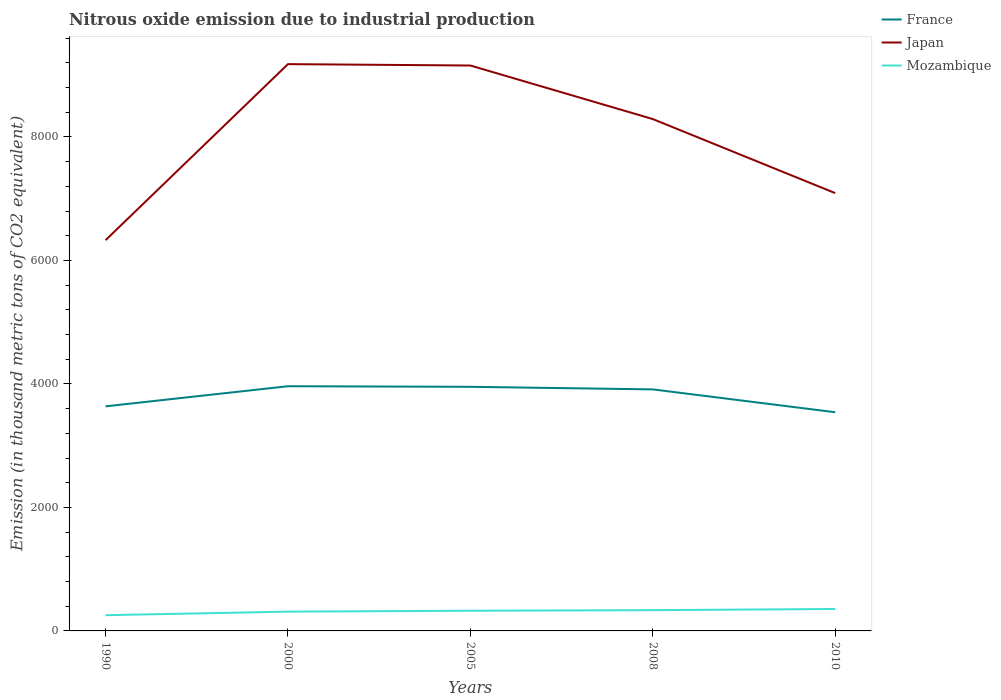Does the line corresponding to Japan intersect with the line corresponding to Mozambique?
Your response must be concise. No. Is the number of lines equal to the number of legend labels?
Your response must be concise. Yes. Across all years, what is the maximum amount of nitrous oxide emitted in Japan?
Offer a very short reply. 6328.4. In which year was the amount of nitrous oxide emitted in France maximum?
Your answer should be very brief. 2010. What is the total amount of nitrous oxide emitted in Mozambique in the graph?
Keep it short and to the point. -100.5. What is the difference between the highest and the second highest amount of nitrous oxide emitted in France?
Keep it short and to the point. 421.1. What is the difference between the highest and the lowest amount of nitrous oxide emitted in Mozambique?
Ensure brevity in your answer.  3. What is the difference between two consecutive major ticks on the Y-axis?
Keep it short and to the point. 2000. Does the graph contain any zero values?
Provide a short and direct response. No. Does the graph contain grids?
Ensure brevity in your answer.  No. How many legend labels are there?
Provide a succinct answer. 3. What is the title of the graph?
Keep it short and to the point. Nitrous oxide emission due to industrial production. Does "Saudi Arabia" appear as one of the legend labels in the graph?
Make the answer very short. No. What is the label or title of the Y-axis?
Offer a very short reply. Emission (in thousand metric tons of CO2 equivalent). What is the Emission (in thousand metric tons of CO2 equivalent) of France in 1990?
Provide a short and direct response. 3637.1. What is the Emission (in thousand metric tons of CO2 equivalent) in Japan in 1990?
Keep it short and to the point. 6328.4. What is the Emission (in thousand metric tons of CO2 equivalent) of Mozambique in 1990?
Keep it short and to the point. 254.8. What is the Emission (in thousand metric tons of CO2 equivalent) of France in 2000?
Keep it short and to the point. 3963. What is the Emission (in thousand metric tons of CO2 equivalent) of Japan in 2000?
Your answer should be very brief. 9179.4. What is the Emission (in thousand metric tons of CO2 equivalent) of Mozambique in 2000?
Make the answer very short. 312.2. What is the Emission (in thousand metric tons of CO2 equivalent) in France in 2005?
Your answer should be very brief. 3953.5. What is the Emission (in thousand metric tons of CO2 equivalent) of Japan in 2005?
Ensure brevity in your answer.  9157. What is the Emission (in thousand metric tons of CO2 equivalent) in Mozambique in 2005?
Offer a terse response. 326.9. What is the Emission (in thousand metric tons of CO2 equivalent) in France in 2008?
Offer a very short reply. 3911.7. What is the Emission (in thousand metric tons of CO2 equivalent) in Japan in 2008?
Make the answer very short. 8290. What is the Emission (in thousand metric tons of CO2 equivalent) of Mozambique in 2008?
Give a very brief answer. 336.3. What is the Emission (in thousand metric tons of CO2 equivalent) in France in 2010?
Your response must be concise. 3541.9. What is the Emission (in thousand metric tons of CO2 equivalent) of Japan in 2010?
Provide a short and direct response. 7090.6. What is the Emission (in thousand metric tons of CO2 equivalent) of Mozambique in 2010?
Your answer should be compact. 355.3. Across all years, what is the maximum Emission (in thousand metric tons of CO2 equivalent) in France?
Your answer should be compact. 3963. Across all years, what is the maximum Emission (in thousand metric tons of CO2 equivalent) in Japan?
Provide a short and direct response. 9179.4. Across all years, what is the maximum Emission (in thousand metric tons of CO2 equivalent) of Mozambique?
Provide a succinct answer. 355.3. Across all years, what is the minimum Emission (in thousand metric tons of CO2 equivalent) in France?
Give a very brief answer. 3541.9. Across all years, what is the minimum Emission (in thousand metric tons of CO2 equivalent) in Japan?
Your answer should be compact. 6328.4. Across all years, what is the minimum Emission (in thousand metric tons of CO2 equivalent) of Mozambique?
Your answer should be compact. 254.8. What is the total Emission (in thousand metric tons of CO2 equivalent) of France in the graph?
Your answer should be compact. 1.90e+04. What is the total Emission (in thousand metric tons of CO2 equivalent) of Japan in the graph?
Offer a terse response. 4.00e+04. What is the total Emission (in thousand metric tons of CO2 equivalent) in Mozambique in the graph?
Ensure brevity in your answer.  1585.5. What is the difference between the Emission (in thousand metric tons of CO2 equivalent) of France in 1990 and that in 2000?
Give a very brief answer. -325.9. What is the difference between the Emission (in thousand metric tons of CO2 equivalent) of Japan in 1990 and that in 2000?
Offer a terse response. -2851. What is the difference between the Emission (in thousand metric tons of CO2 equivalent) of Mozambique in 1990 and that in 2000?
Your answer should be compact. -57.4. What is the difference between the Emission (in thousand metric tons of CO2 equivalent) of France in 1990 and that in 2005?
Your answer should be compact. -316.4. What is the difference between the Emission (in thousand metric tons of CO2 equivalent) in Japan in 1990 and that in 2005?
Your answer should be compact. -2828.6. What is the difference between the Emission (in thousand metric tons of CO2 equivalent) in Mozambique in 1990 and that in 2005?
Your answer should be very brief. -72.1. What is the difference between the Emission (in thousand metric tons of CO2 equivalent) in France in 1990 and that in 2008?
Your response must be concise. -274.6. What is the difference between the Emission (in thousand metric tons of CO2 equivalent) in Japan in 1990 and that in 2008?
Your response must be concise. -1961.6. What is the difference between the Emission (in thousand metric tons of CO2 equivalent) of Mozambique in 1990 and that in 2008?
Your response must be concise. -81.5. What is the difference between the Emission (in thousand metric tons of CO2 equivalent) in France in 1990 and that in 2010?
Provide a short and direct response. 95.2. What is the difference between the Emission (in thousand metric tons of CO2 equivalent) in Japan in 1990 and that in 2010?
Provide a short and direct response. -762.2. What is the difference between the Emission (in thousand metric tons of CO2 equivalent) of Mozambique in 1990 and that in 2010?
Your response must be concise. -100.5. What is the difference between the Emission (in thousand metric tons of CO2 equivalent) in France in 2000 and that in 2005?
Keep it short and to the point. 9.5. What is the difference between the Emission (in thousand metric tons of CO2 equivalent) in Japan in 2000 and that in 2005?
Ensure brevity in your answer.  22.4. What is the difference between the Emission (in thousand metric tons of CO2 equivalent) of Mozambique in 2000 and that in 2005?
Provide a succinct answer. -14.7. What is the difference between the Emission (in thousand metric tons of CO2 equivalent) in France in 2000 and that in 2008?
Your answer should be very brief. 51.3. What is the difference between the Emission (in thousand metric tons of CO2 equivalent) of Japan in 2000 and that in 2008?
Your response must be concise. 889.4. What is the difference between the Emission (in thousand metric tons of CO2 equivalent) of Mozambique in 2000 and that in 2008?
Your answer should be compact. -24.1. What is the difference between the Emission (in thousand metric tons of CO2 equivalent) of France in 2000 and that in 2010?
Provide a succinct answer. 421.1. What is the difference between the Emission (in thousand metric tons of CO2 equivalent) of Japan in 2000 and that in 2010?
Offer a very short reply. 2088.8. What is the difference between the Emission (in thousand metric tons of CO2 equivalent) of Mozambique in 2000 and that in 2010?
Keep it short and to the point. -43.1. What is the difference between the Emission (in thousand metric tons of CO2 equivalent) of France in 2005 and that in 2008?
Keep it short and to the point. 41.8. What is the difference between the Emission (in thousand metric tons of CO2 equivalent) in Japan in 2005 and that in 2008?
Make the answer very short. 867. What is the difference between the Emission (in thousand metric tons of CO2 equivalent) in Mozambique in 2005 and that in 2008?
Your response must be concise. -9.4. What is the difference between the Emission (in thousand metric tons of CO2 equivalent) in France in 2005 and that in 2010?
Give a very brief answer. 411.6. What is the difference between the Emission (in thousand metric tons of CO2 equivalent) in Japan in 2005 and that in 2010?
Provide a short and direct response. 2066.4. What is the difference between the Emission (in thousand metric tons of CO2 equivalent) in Mozambique in 2005 and that in 2010?
Keep it short and to the point. -28.4. What is the difference between the Emission (in thousand metric tons of CO2 equivalent) of France in 2008 and that in 2010?
Offer a very short reply. 369.8. What is the difference between the Emission (in thousand metric tons of CO2 equivalent) of Japan in 2008 and that in 2010?
Offer a very short reply. 1199.4. What is the difference between the Emission (in thousand metric tons of CO2 equivalent) of France in 1990 and the Emission (in thousand metric tons of CO2 equivalent) of Japan in 2000?
Make the answer very short. -5542.3. What is the difference between the Emission (in thousand metric tons of CO2 equivalent) in France in 1990 and the Emission (in thousand metric tons of CO2 equivalent) in Mozambique in 2000?
Your response must be concise. 3324.9. What is the difference between the Emission (in thousand metric tons of CO2 equivalent) in Japan in 1990 and the Emission (in thousand metric tons of CO2 equivalent) in Mozambique in 2000?
Give a very brief answer. 6016.2. What is the difference between the Emission (in thousand metric tons of CO2 equivalent) in France in 1990 and the Emission (in thousand metric tons of CO2 equivalent) in Japan in 2005?
Give a very brief answer. -5519.9. What is the difference between the Emission (in thousand metric tons of CO2 equivalent) of France in 1990 and the Emission (in thousand metric tons of CO2 equivalent) of Mozambique in 2005?
Your answer should be very brief. 3310.2. What is the difference between the Emission (in thousand metric tons of CO2 equivalent) of Japan in 1990 and the Emission (in thousand metric tons of CO2 equivalent) of Mozambique in 2005?
Provide a short and direct response. 6001.5. What is the difference between the Emission (in thousand metric tons of CO2 equivalent) in France in 1990 and the Emission (in thousand metric tons of CO2 equivalent) in Japan in 2008?
Offer a very short reply. -4652.9. What is the difference between the Emission (in thousand metric tons of CO2 equivalent) in France in 1990 and the Emission (in thousand metric tons of CO2 equivalent) in Mozambique in 2008?
Your answer should be compact. 3300.8. What is the difference between the Emission (in thousand metric tons of CO2 equivalent) of Japan in 1990 and the Emission (in thousand metric tons of CO2 equivalent) of Mozambique in 2008?
Your answer should be compact. 5992.1. What is the difference between the Emission (in thousand metric tons of CO2 equivalent) of France in 1990 and the Emission (in thousand metric tons of CO2 equivalent) of Japan in 2010?
Your answer should be very brief. -3453.5. What is the difference between the Emission (in thousand metric tons of CO2 equivalent) in France in 1990 and the Emission (in thousand metric tons of CO2 equivalent) in Mozambique in 2010?
Your answer should be very brief. 3281.8. What is the difference between the Emission (in thousand metric tons of CO2 equivalent) of Japan in 1990 and the Emission (in thousand metric tons of CO2 equivalent) of Mozambique in 2010?
Keep it short and to the point. 5973.1. What is the difference between the Emission (in thousand metric tons of CO2 equivalent) of France in 2000 and the Emission (in thousand metric tons of CO2 equivalent) of Japan in 2005?
Make the answer very short. -5194. What is the difference between the Emission (in thousand metric tons of CO2 equivalent) of France in 2000 and the Emission (in thousand metric tons of CO2 equivalent) of Mozambique in 2005?
Ensure brevity in your answer.  3636.1. What is the difference between the Emission (in thousand metric tons of CO2 equivalent) of Japan in 2000 and the Emission (in thousand metric tons of CO2 equivalent) of Mozambique in 2005?
Your response must be concise. 8852.5. What is the difference between the Emission (in thousand metric tons of CO2 equivalent) in France in 2000 and the Emission (in thousand metric tons of CO2 equivalent) in Japan in 2008?
Your answer should be very brief. -4327. What is the difference between the Emission (in thousand metric tons of CO2 equivalent) of France in 2000 and the Emission (in thousand metric tons of CO2 equivalent) of Mozambique in 2008?
Make the answer very short. 3626.7. What is the difference between the Emission (in thousand metric tons of CO2 equivalent) in Japan in 2000 and the Emission (in thousand metric tons of CO2 equivalent) in Mozambique in 2008?
Give a very brief answer. 8843.1. What is the difference between the Emission (in thousand metric tons of CO2 equivalent) in France in 2000 and the Emission (in thousand metric tons of CO2 equivalent) in Japan in 2010?
Your answer should be compact. -3127.6. What is the difference between the Emission (in thousand metric tons of CO2 equivalent) of France in 2000 and the Emission (in thousand metric tons of CO2 equivalent) of Mozambique in 2010?
Keep it short and to the point. 3607.7. What is the difference between the Emission (in thousand metric tons of CO2 equivalent) of Japan in 2000 and the Emission (in thousand metric tons of CO2 equivalent) of Mozambique in 2010?
Offer a very short reply. 8824.1. What is the difference between the Emission (in thousand metric tons of CO2 equivalent) of France in 2005 and the Emission (in thousand metric tons of CO2 equivalent) of Japan in 2008?
Give a very brief answer. -4336.5. What is the difference between the Emission (in thousand metric tons of CO2 equivalent) of France in 2005 and the Emission (in thousand metric tons of CO2 equivalent) of Mozambique in 2008?
Your response must be concise. 3617.2. What is the difference between the Emission (in thousand metric tons of CO2 equivalent) in Japan in 2005 and the Emission (in thousand metric tons of CO2 equivalent) in Mozambique in 2008?
Keep it short and to the point. 8820.7. What is the difference between the Emission (in thousand metric tons of CO2 equivalent) of France in 2005 and the Emission (in thousand metric tons of CO2 equivalent) of Japan in 2010?
Make the answer very short. -3137.1. What is the difference between the Emission (in thousand metric tons of CO2 equivalent) of France in 2005 and the Emission (in thousand metric tons of CO2 equivalent) of Mozambique in 2010?
Your answer should be compact. 3598.2. What is the difference between the Emission (in thousand metric tons of CO2 equivalent) in Japan in 2005 and the Emission (in thousand metric tons of CO2 equivalent) in Mozambique in 2010?
Your answer should be compact. 8801.7. What is the difference between the Emission (in thousand metric tons of CO2 equivalent) of France in 2008 and the Emission (in thousand metric tons of CO2 equivalent) of Japan in 2010?
Ensure brevity in your answer.  -3178.9. What is the difference between the Emission (in thousand metric tons of CO2 equivalent) in France in 2008 and the Emission (in thousand metric tons of CO2 equivalent) in Mozambique in 2010?
Offer a terse response. 3556.4. What is the difference between the Emission (in thousand metric tons of CO2 equivalent) of Japan in 2008 and the Emission (in thousand metric tons of CO2 equivalent) of Mozambique in 2010?
Provide a succinct answer. 7934.7. What is the average Emission (in thousand metric tons of CO2 equivalent) in France per year?
Ensure brevity in your answer.  3801.44. What is the average Emission (in thousand metric tons of CO2 equivalent) of Japan per year?
Make the answer very short. 8009.08. What is the average Emission (in thousand metric tons of CO2 equivalent) of Mozambique per year?
Offer a very short reply. 317.1. In the year 1990, what is the difference between the Emission (in thousand metric tons of CO2 equivalent) in France and Emission (in thousand metric tons of CO2 equivalent) in Japan?
Ensure brevity in your answer.  -2691.3. In the year 1990, what is the difference between the Emission (in thousand metric tons of CO2 equivalent) in France and Emission (in thousand metric tons of CO2 equivalent) in Mozambique?
Provide a short and direct response. 3382.3. In the year 1990, what is the difference between the Emission (in thousand metric tons of CO2 equivalent) in Japan and Emission (in thousand metric tons of CO2 equivalent) in Mozambique?
Your response must be concise. 6073.6. In the year 2000, what is the difference between the Emission (in thousand metric tons of CO2 equivalent) of France and Emission (in thousand metric tons of CO2 equivalent) of Japan?
Make the answer very short. -5216.4. In the year 2000, what is the difference between the Emission (in thousand metric tons of CO2 equivalent) in France and Emission (in thousand metric tons of CO2 equivalent) in Mozambique?
Give a very brief answer. 3650.8. In the year 2000, what is the difference between the Emission (in thousand metric tons of CO2 equivalent) in Japan and Emission (in thousand metric tons of CO2 equivalent) in Mozambique?
Offer a terse response. 8867.2. In the year 2005, what is the difference between the Emission (in thousand metric tons of CO2 equivalent) of France and Emission (in thousand metric tons of CO2 equivalent) of Japan?
Ensure brevity in your answer.  -5203.5. In the year 2005, what is the difference between the Emission (in thousand metric tons of CO2 equivalent) in France and Emission (in thousand metric tons of CO2 equivalent) in Mozambique?
Provide a succinct answer. 3626.6. In the year 2005, what is the difference between the Emission (in thousand metric tons of CO2 equivalent) in Japan and Emission (in thousand metric tons of CO2 equivalent) in Mozambique?
Provide a short and direct response. 8830.1. In the year 2008, what is the difference between the Emission (in thousand metric tons of CO2 equivalent) of France and Emission (in thousand metric tons of CO2 equivalent) of Japan?
Your answer should be very brief. -4378.3. In the year 2008, what is the difference between the Emission (in thousand metric tons of CO2 equivalent) of France and Emission (in thousand metric tons of CO2 equivalent) of Mozambique?
Give a very brief answer. 3575.4. In the year 2008, what is the difference between the Emission (in thousand metric tons of CO2 equivalent) in Japan and Emission (in thousand metric tons of CO2 equivalent) in Mozambique?
Ensure brevity in your answer.  7953.7. In the year 2010, what is the difference between the Emission (in thousand metric tons of CO2 equivalent) in France and Emission (in thousand metric tons of CO2 equivalent) in Japan?
Provide a succinct answer. -3548.7. In the year 2010, what is the difference between the Emission (in thousand metric tons of CO2 equivalent) of France and Emission (in thousand metric tons of CO2 equivalent) of Mozambique?
Provide a succinct answer. 3186.6. In the year 2010, what is the difference between the Emission (in thousand metric tons of CO2 equivalent) of Japan and Emission (in thousand metric tons of CO2 equivalent) of Mozambique?
Provide a short and direct response. 6735.3. What is the ratio of the Emission (in thousand metric tons of CO2 equivalent) of France in 1990 to that in 2000?
Keep it short and to the point. 0.92. What is the ratio of the Emission (in thousand metric tons of CO2 equivalent) of Japan in 1990 to that in 2000?
Keep it short and to the point. 0.69. What is the ratio of the Emission (in thousand metric tons of CO2 equivalent) in Mozambique in 1990 to that in 2000?
Make the answer very short. 0.82. What is the ratio of the Emission (in thousand metric tons of CO2 equivalent) in Japan in 1990 to that in 2005?
Offer a terse response. 0.69. What is the ratio of the Emission (in thousand metric tons of CO2 equivalent) of Mozambique in 1990 to that in 2005?
Make the answer very short. 0.78. What is the ratio of the Emission (in thousand metric tons of CO2 equivalent) of France in 1990 to that in 2008?
Your answer should be very brief. 0.93. What is the ratio of the Emission (in thousand metric tons of CO2 equivalent) of Japan in 1990 to that in 2008?
Make the answer very short. 0.76. What is the ratio of the Emission (in thousand metric tons of CO2 equivalent) of Mozambique in 1990 to that in 2008?
Keep it short and to the point. 0.76. What is the ratio of the Emission (in thousand metric tons of CO2 equivalent) in France in 1990 to that in 2010?
Ensure brevity in your answer.  1.03. What is the ratio of the Emission (in thousand metric tons of CO2 equivalent) of Japan in 1990 to that in 2010?
Your response must be concise. 0.89. What is the ratio of the Emission (in thousand metric tons of CO2 equivalent) of Mozambique in 1990 to that in 2010?
Offer a terse response. 0.72. What is the ratio of the Emission (in thousand metric tons of CO2 equivalent) of France in 2000 to that in 2005?
Your answer should be compact. 1. What is the ratio of the Emission (in thousand metric tons of CO2 equivalent) in Japan in 2000 to that in 2005?
Keep it short and to the point. 1. What is the ratio of the Emission (in thousand metric tons of CO2 equivalent) of Mozambique in 2000 to that in 2005?
Keep it short and to the point. 0.95. What is the ratio of the Emission (in thousand metric tons of CO2 equivalent) of France in 2000 to that in 2008?
Provide a succinct answer. 1.01. What is the ratio of the Emission (in thousand metric tons of CO2 equivalent) in Japan in 2000 to that in 2008?
Ensure brevity in your answer.  1.11. What is the ratio of the Emission (in thousand metric tons of CO2 equivalent) of Mozambique in 2000 to that in 2008?
Ensure brevity in your answer.  0.93. What is the ratio of the Emission (in thousand metric tons of CO2 equivalent) in France in 2000 to that in 2010?
Your answer should be very brief. 1.12. What is the ratio of the Emission (in thousand metric tons of CO2 equivalent) of Japan in 2000 to that in 2010?
Offer a terse response. 1.29. What is the ratio of the Emission (in thousand metric tons of CO2 equivalent) of Mozambique in 2000 to that in 2010?
Give a very brief answer. 0.88. What is the ratio of the Emission (in thousand metric tons of CO2 equivalent) in France in 2005 to that in 2008?
Ensure brevity in your answer.  1.01. What is the ratio of the Emission (in thousand metric tons of CO2 equivalent) in Japan in 2005 to that in 2008?
Provide a short and direct response. 1.1. What is the ratio of the Emission (in thousand metric tons of CO2 equivalent) in France in 2005 to that in 2010?
Offer a terse response. 1.12. What is the ratio of the Emission (in thousand metric tons of CO2 equivalent) of Japan in 2005 to that in 2010?
Provide a short and direct response. 1.29. What is the ratio of the Emission (in thousand metric tons of CO2 equivalent) of Mozambique in 2005 to that in 2010?
Keep it short and to the point. 0.92. What is the ratio of the Emission (in thousand metric tons of CO2 equivalent) of France in 2008 to that in 2010?
Offer a very short reply. 1.1. What is the ratio of the Emission (in thousand metric tons of CO2 equivalent) of Japan in 2008 to that in 2010?
Your answer should be very brief. 1.17. What is the ratio of the Emission (in thousand metric tons of CO2 equivalent) of Mozambique in 2008 to that in 2010?
Your response must be concise. 0.95. What is the difference between the highest and the second highest Emission (in thousand metric tons of CO2 equivalent) of Japan?
Provide a succinct answer. 22.4. What is the difference between the highest and the lowest Emission (in thousand metric tons of CO2 equivalent) of France?
Your answer should be very brief. 421.1. What is the difference between the highest and the lowest Emission (in thousand metric tons of CO2 equivalent) in Japan?
Provide a succinct answer. 2851. What is the difference between the highest and the lowest Emission (in thousand metric tons of CO2 equivalent) of Mozambique?
Offer a very short reply. 100.5. 